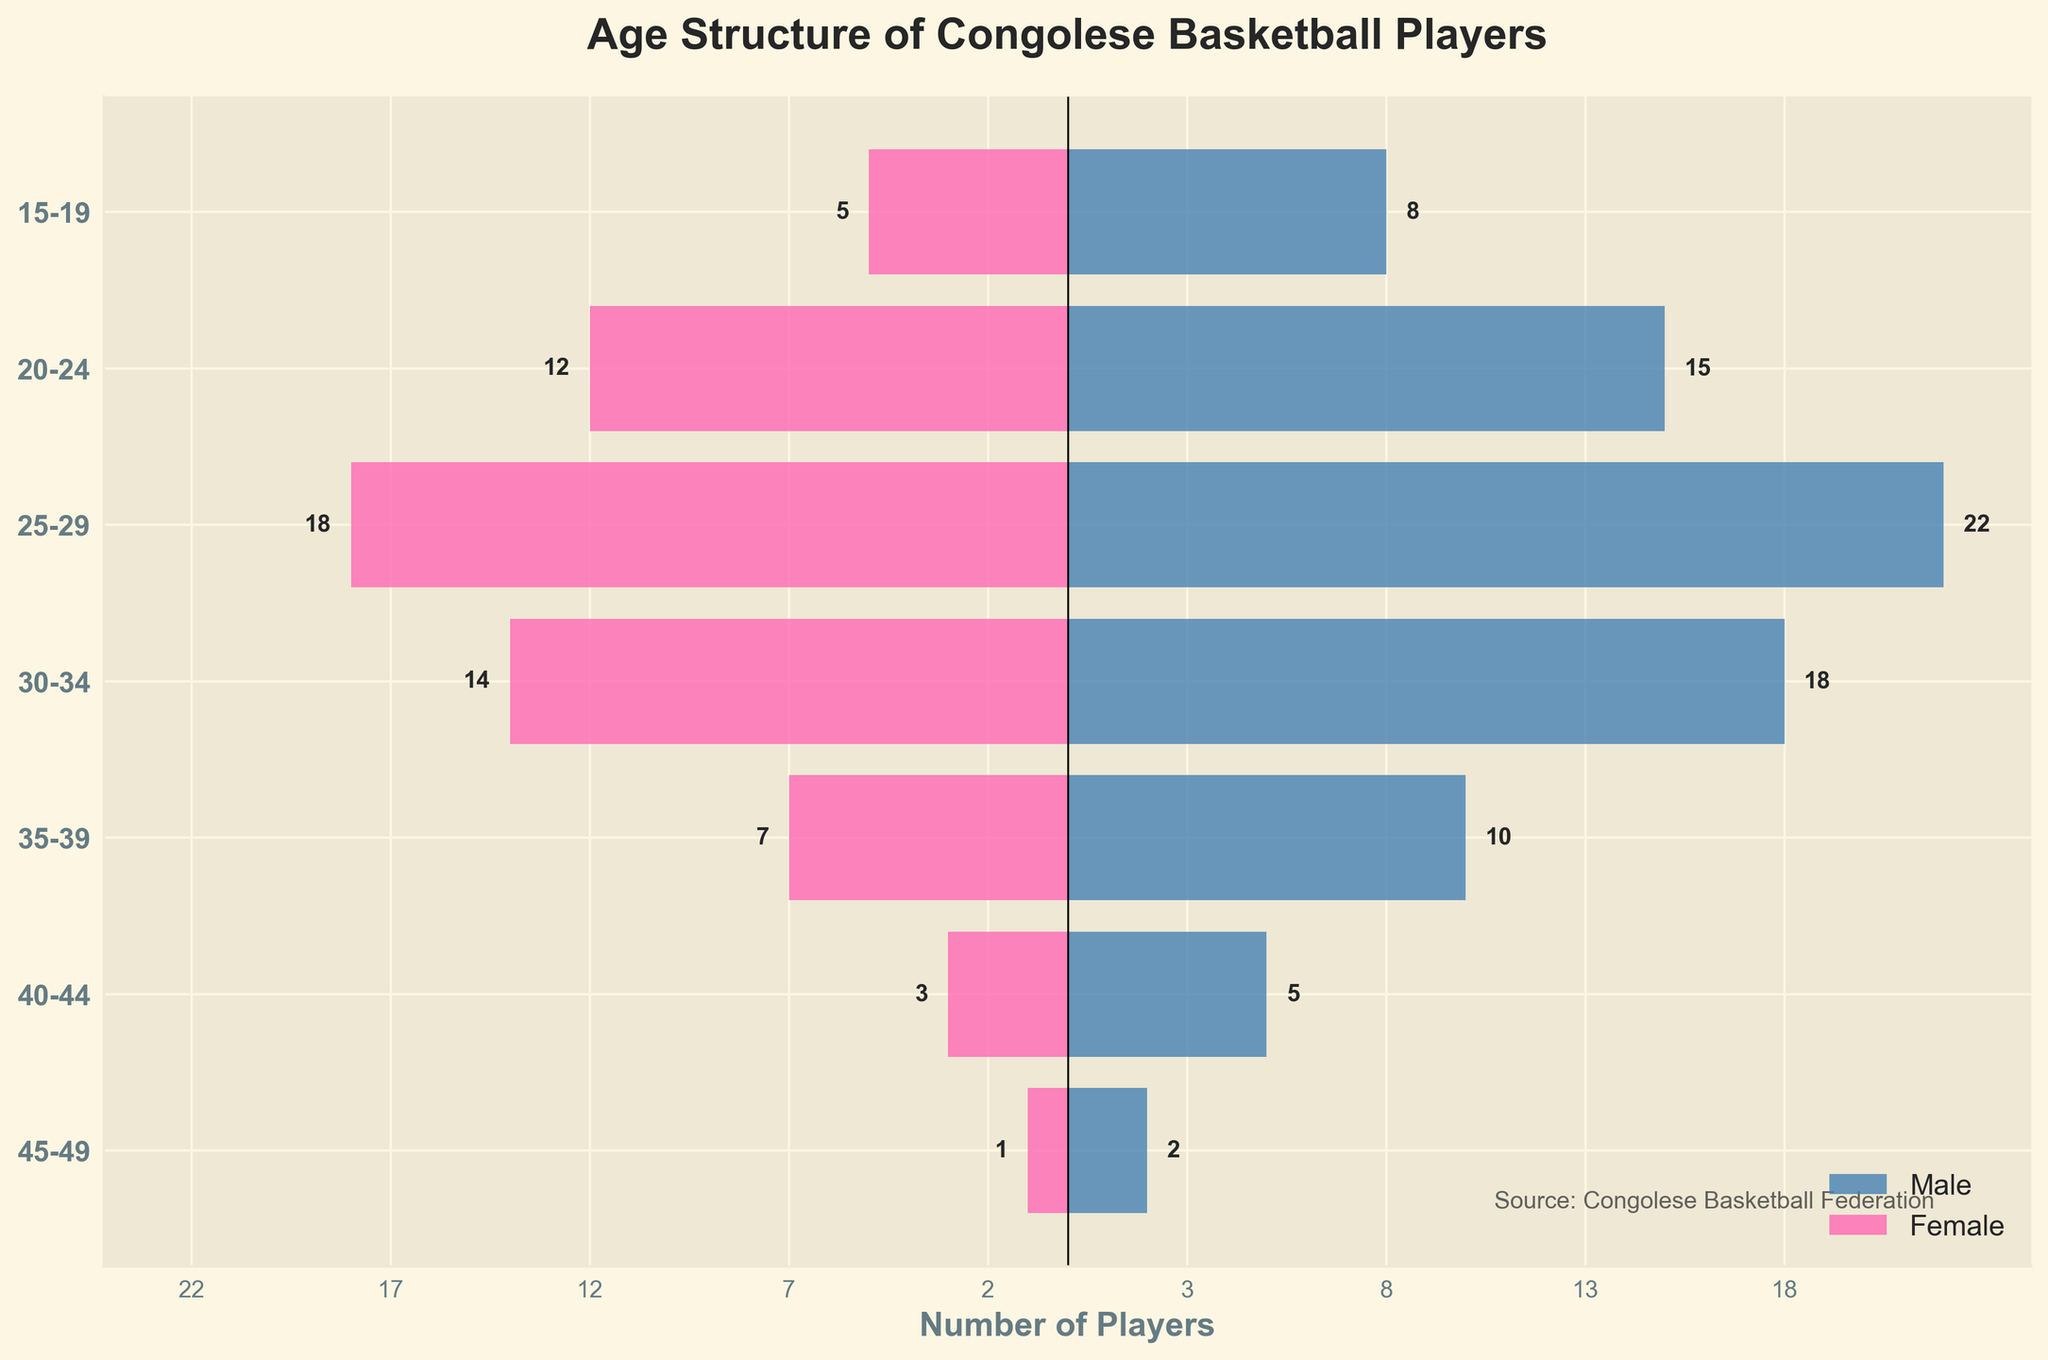what is the age range of the youngest male and female basketball players? The youngest male basketball players' age range is found where the highest bar for males begins on the left, which is 15-19. The youngest female basketball players' age range is found where the highest bar for females begins on the right, which is also 15-19.
Answer: 15-19 Which age group has the highest number of male basketball players? To identify the age group with the highest number of male basketball players, look for the bar extending furthest to the right. The age 25-29 has the highest number of male players, at 22.
Answer: 25-29 What is the total number of female players in the 30-34 age range? Locate the female bar in the 30-34 age range and look at its length, which is 14. Thus, there are 14 female players in this age range.
Answer: 14 Compare the number of male and female basketball players in the 20-24 age range. Which gender has more players, and by how many? The male bar for the age range 20-24 extends to 15, while the female bar extends to -12. The number of male players (15) is greater by 3 compared to the number of female players (12).
Answer: Male by 3 players How many more male basketball players are there in the age range 30-34 compared to the age range 35-39? To find the difference: Number of male players aged 30-34 is 18, and aged 35-39 is 10. So, 18 - 10 = 8.
Answer: 8 What is the total number of basketball players (both male and female) in the age range 25-29? Add the number of male players (22) and female players (18) in the age range 25-29. 22 + 18 = 40.
Answer: 40 Which age group has the least number of female basketball players? Look for the shortest female bar on the left. The smallest bar is for the age range 45-49, with only 1 female player.
Answer: 45-49 If you combined the total number of players aged 15-19 and 20-24, how many players would you have? Sum the male and female players for both age ranges. For 15-19: 8 (male) + 5 (female) = 13. For 20-24: 15 (male) + 12 (female) = 27. Combine both ranges: 13 + 27 = 40.
Answer: 40 In which age range is the gender gap (difference between male and female players) the largest? Find the age range where the difference between the number of male and female players is the greatest. For 25-29: 22 (male) - 18 (female) = 4, Other differences are less than 4.
Answer: 25-29 What is the total number of basketball players aged 40 and above? Add the number of male and female players in the 40-44 and 45-49 age ranges. For 40-44: 5 (male) + 3 (female) = 8. For 45-49: 2 (male) + 1 (female) = 3. Combine both ranges: 8 + 3 = 11.
Answer: 11 